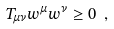Convert formula to latex. <formula><loc_0><loc_0><loc_500><loc_500>T _ { \mu \nu } w ^ { \mu } w ^ { \nu } \geq 0 \ ,</formula> 